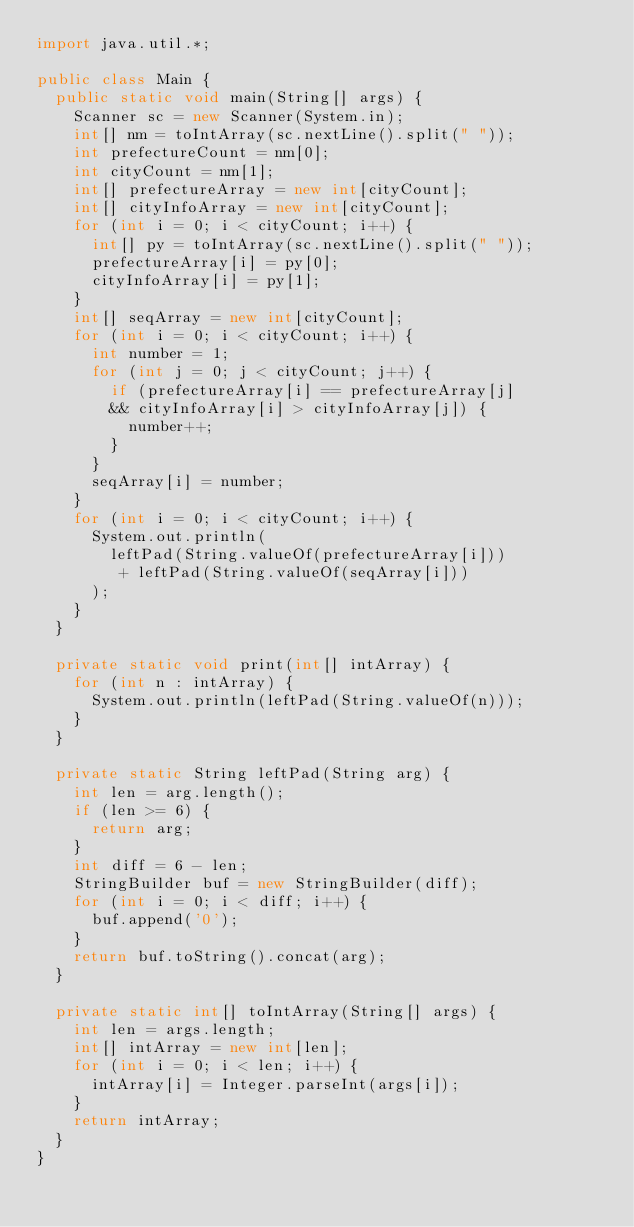Convert code to text. <code><loc_0><loc_0><loc_500><loc_500><_Java_>import java.util.*;

public class Main {
	public static void main(String[] args) {
		Scanner sc = new Scanner(System.in);
		int[] nm = toIntArray(sc.nextLine().split(" "));
		int prefectureCount = nm[0];
		int cityCount = nm[1];
		int[] prefectureArray = new int[cityCount];
		int[] cityInfoArray = new int[cityCount];
		for (int i = 0; i < cityCount; i++) {
			int[] py = toIntArray(sc.nextLine().split(" "));
			prefectureArray[i] = py[0];
			cityInfoArray[i] = py[1];
		}
		int[] seqArray = new int[cityCount];
		for (int i = 0; i < cityCount; i++) {
			int number = 1;
			for (int j = 0; j < cityCount; j++) {
				if (prefectureArray[i] == prefectureArray[j]
				&& cityInfoArray[i] > cityInfoArray[j]) {
					number++;
				}
			}
			seqArray[i] = number;
		}
		for (int i = 0; i < cityCount; i++) {
			System.out.println(
				leftPad(String.valueOf(prefectureArray[i]))
				 + leftPad(String.valueOf(seqArray[i]))
			);
		}
	}

	private static void print(int[] intArray) {
		for (int n : intArray) {
			System.out.println(leftPad(String.valueOf(n)));
		}
	}

	private static String leftPad(String arg) {
		int len = arg.length();
		if (len >= 6) {
			return arg;
		}
		int diff = 6 - len;
		StringBuilder buf = new StringBuilder(diff);
		for (int i = 0; i < diff; i++) {
			buf.append('0');
		}
		return buf.toString().concat(arg);
	}

	private static int[] toIntArray(String[] args) {
		int len = args.length;
		int[] intArray = new int[len];
		for (int i = 0; i < len; i++) {
			intArray[i] = Integer.parseInt(args[i]);
		}
		return intArray;
	}
}
</code> 